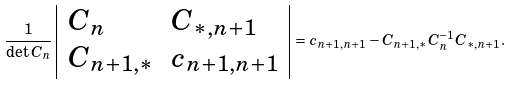<formula> <loc_0><loc_0><loc_500><loc_500>\frac { 1 } { \det C _ { n } } \left | \begin{array} { l l } C _ { n } & C _ { * , n + 1 } \\ C _ { n + 1 , * } & c _ { n + 1 , n + 1 } \end{array} \right | = c _ { n + 1 , n + 1 } - C _ { n + 1 , * } C _ { n } ^ { - 1 } C _ { * , n + 1 } .</formula> 